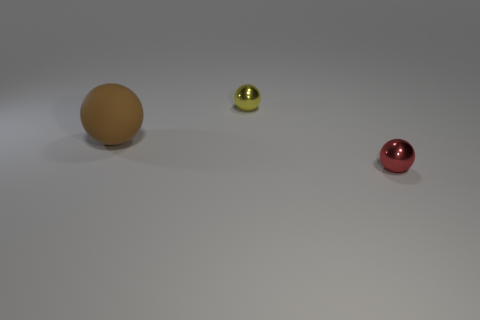Subtract all tiny red metal balls. How many balls are left? 2 Add 2 small cylinders. How many objects exist? 5 Subtract all yellow spheres. How many spheres are left? 2 Subtract 3 balls. How many balls are left? 0 Subtract all green balls. Subtract all gray blocks. How many balls are left? 3 Subtract all gray cylinders. How many cyan spheres are left? 0 Subtract all metal things. Subtract all gray rubber cylinders. How many objects are left? 1 Add 3 small red spheres. How many small red spheres are left? 4 Add 3 blue rubber balls. How many blue rubber balls exist? 3 Subtract 0 gray cubes. How many objects are left? 3 